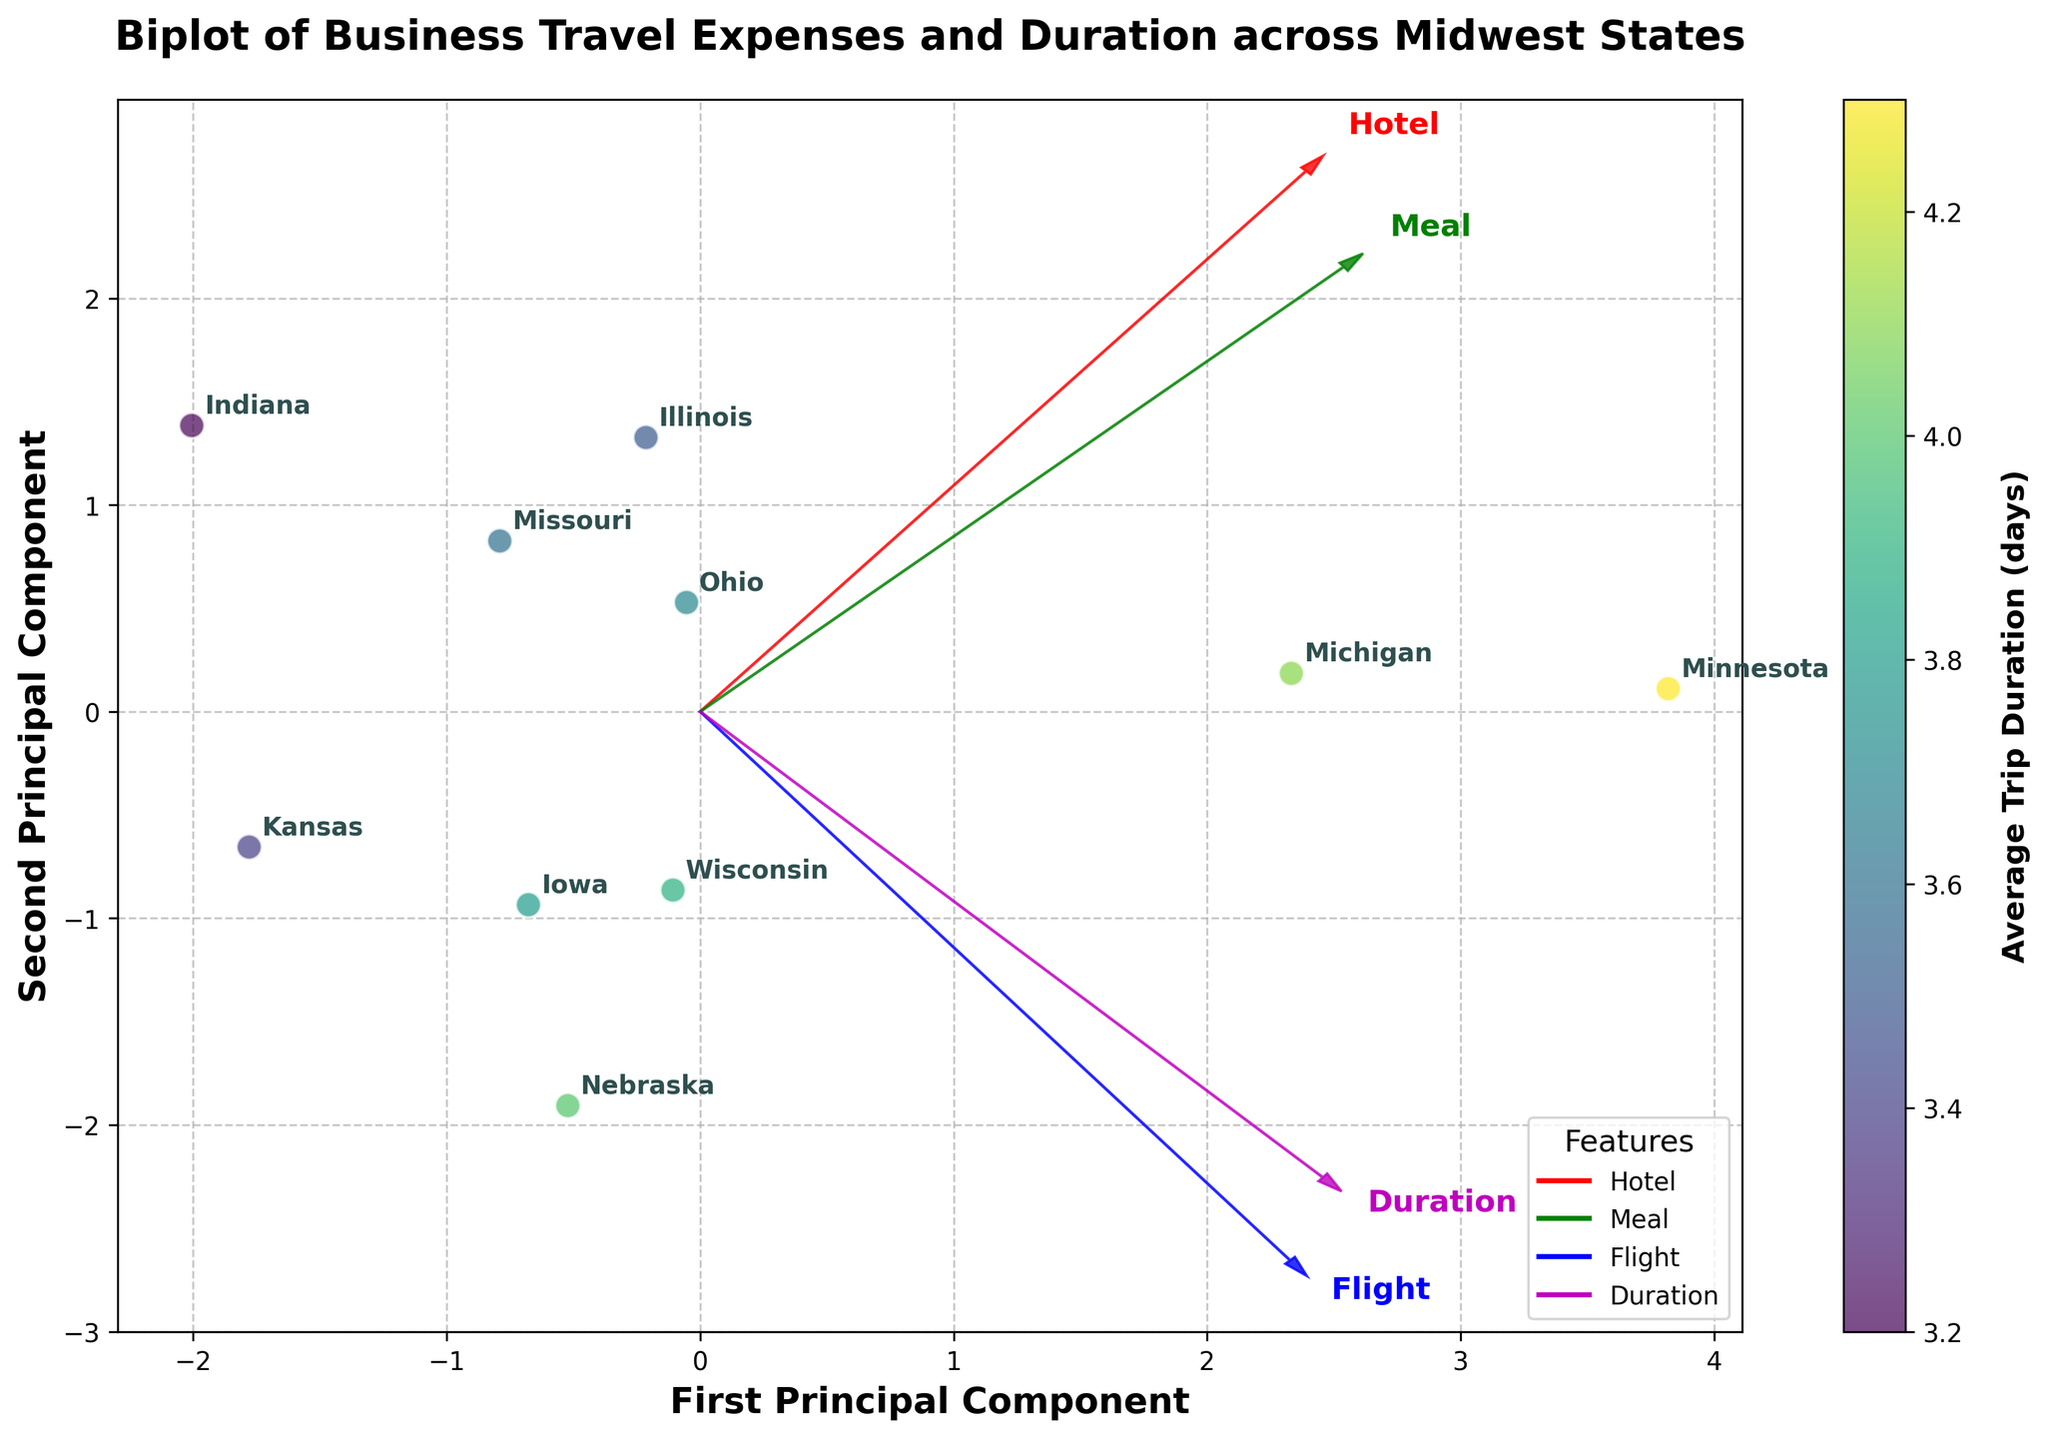How many states are included in the plot? Count the number of labels, which represent the states in the scatter plot.
Answer: 10 What is the title of the plot? Look at the top of the plot where the title is usually placed.
Answer: Biplot of Business Travel Expenses and Duration across Midwest States Which state has the highest Average Trip Duration according to the color scale? Observe the state data points with the highest color value in the color scale, which represents the Average Trip Duration.
Answer: Minnesota Which feature vector has the most pronounced direction in the first principal component? Compare the length of the arrows representing the feature vectors along the first principal component. The one with the longest arrow has the most pronounced direction.
Answer: Flight What are the axes labeled as? Check the labels on the X and Y axes of the plot.
Answer: First Principal Component, Second Principal Component Which state is most closely associated with high average hotel and flight costs? Identify the state closest to the arrows pointing towards higher values on the "Hotel" and "Flight" feature vectors.
Answer: Minnesota Which two states are closest together on the plot? Observe the distances between data points representing states and identify the closest pair.
Answer: Indiana and Ohio How do Nebraska and Kansas compare in terms of Average Meal Cost? Kansas and Nebraska are states, look at their positions relative to the "Meal" vector to compare their meal costs.
Answer: Kansas has a higher meal cost than Nebraska What visual element represents the different features like hotel cost, meal cost, flight cost, and duration? Observe the plot to see what indicates feature vectors.
Answer: Arrows What does the color of the data points represent, and what is its range? See the color scale and description near the scatter plot to determine what the colors indicate and their range.
Answer: Average Trip Duration, 3.2 to 4.3 days 